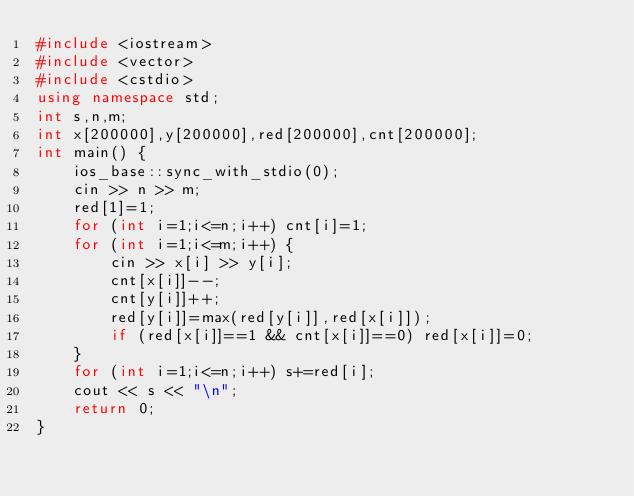Convert code to text. <code><loc_0><loc_0><loc_500><loc_500><_C++_>#include <iostream>
#include <vector>
#include <cstdio>
using namespace std;
int s,n,m;
int x[200000],y[200000],red[200000],cnt[200000];
int main() {
    ios_base::sync_with_stdio(0);
    cin >> n >> m;
    red[1]=1;
    for (int i=1;i<=n;i++) cnt[i]=1;
    for (int i=1;i<=m;i++) {
        cin >> x[i] >> y[i];
        cnt[x[i]]--;
        cnt[y[i]]++;
        red[y[i]]=max(red[y[i]],red[x[i]]);
        if (red[x[i]]==1 && cnt[x[i]]==0) red[x[i]]=0;
    }
    for (int i=1;i<=n;i++) s+=red[i];
    cout << s << "\n";
    return 0;
}
</code> 